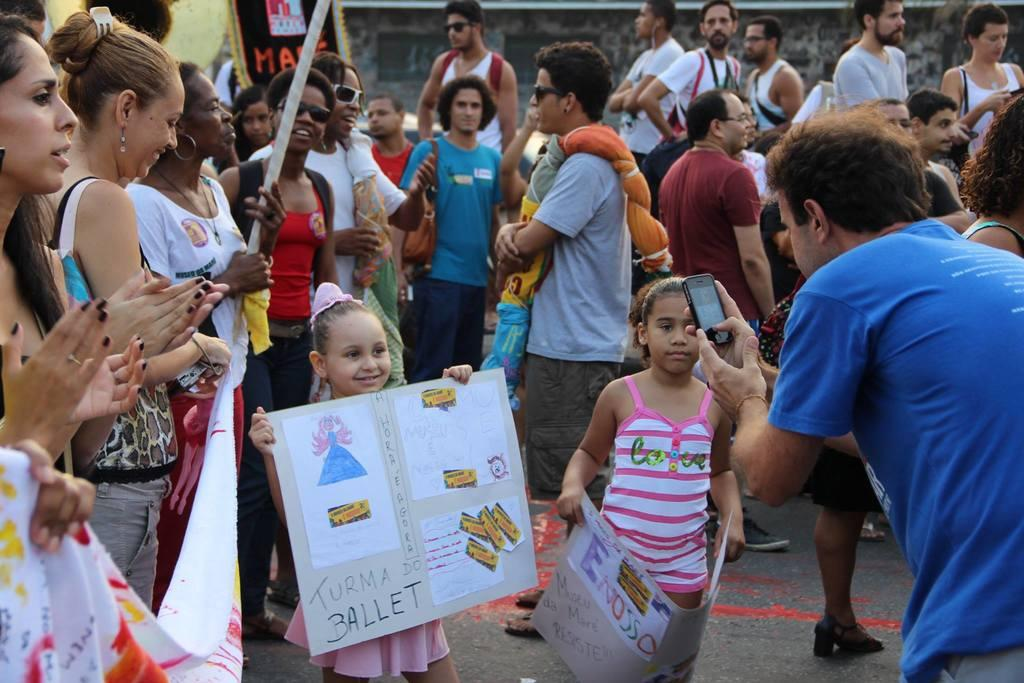What is the main subject of the image? The main subject of the image is a group of people. Can you describe any specific features of the people in the group? Some people in the group are wearing spectacles, and some are holding placards. Where is the man located in the image? The man is on the right side of the image. What is the man holding in the image? The man is holding a mobile. What type of club can be seen in the image? There is no club present in the image; it features a group of people, some of whom are holding placards. What is the spark used for in the image? There is no spark present in the image; it is a group of people holding placards and a man holding a mobile. 